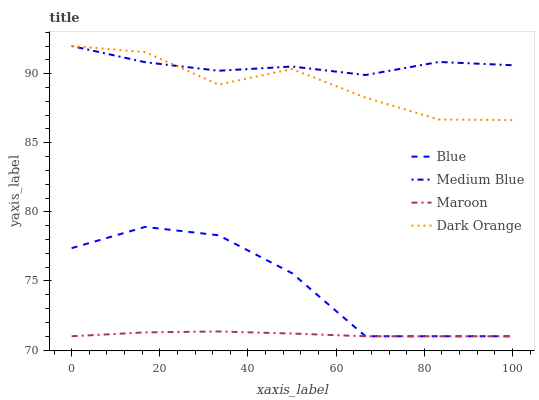Does Maroon have the minimum area under the curve?
Answer yes or no. Yes. Does Medium Blue have the maximum area under the curve?
Answer yes or no. Yes. Does Dark Orange have the minimum area under the curve?
Answer yes or no. No. Does Dark Orange have the maximum area under the curve?
Answer yes or no. No. Is Maroon the smoothest?
Answer yes or no. Yes. Is Blue the roughest?
Answer yes or no. Yes. Is Dark Orange the smoothest?
Answer yes or no. No. Is Dark Orange the roughest?
Answer yes or no. No. Does Blue have the lowest value?
Answer yes or no. Yes. Does Dark Orange have the lowest value?
Answer yes or no. No. Does Medium Blue have the highest value?
Answer yes or no. Yes. Does Maroon have the highest value?
Answer yes or no. No. Is Blue less than Dark Orange?
Answer yes or no. Yes. Is Dark Orange greater than Maroon?
Answer yes or no. Yes. Does Blue intersect Maroon?
Answer yes or no. Yes. Is Blue less than Maroon?
Answer yes or no. No. Is Blue greater than Maroon?
Answer yes or no. No. Does Blue intersect Dark Orange?
Answer yes or no. No. 